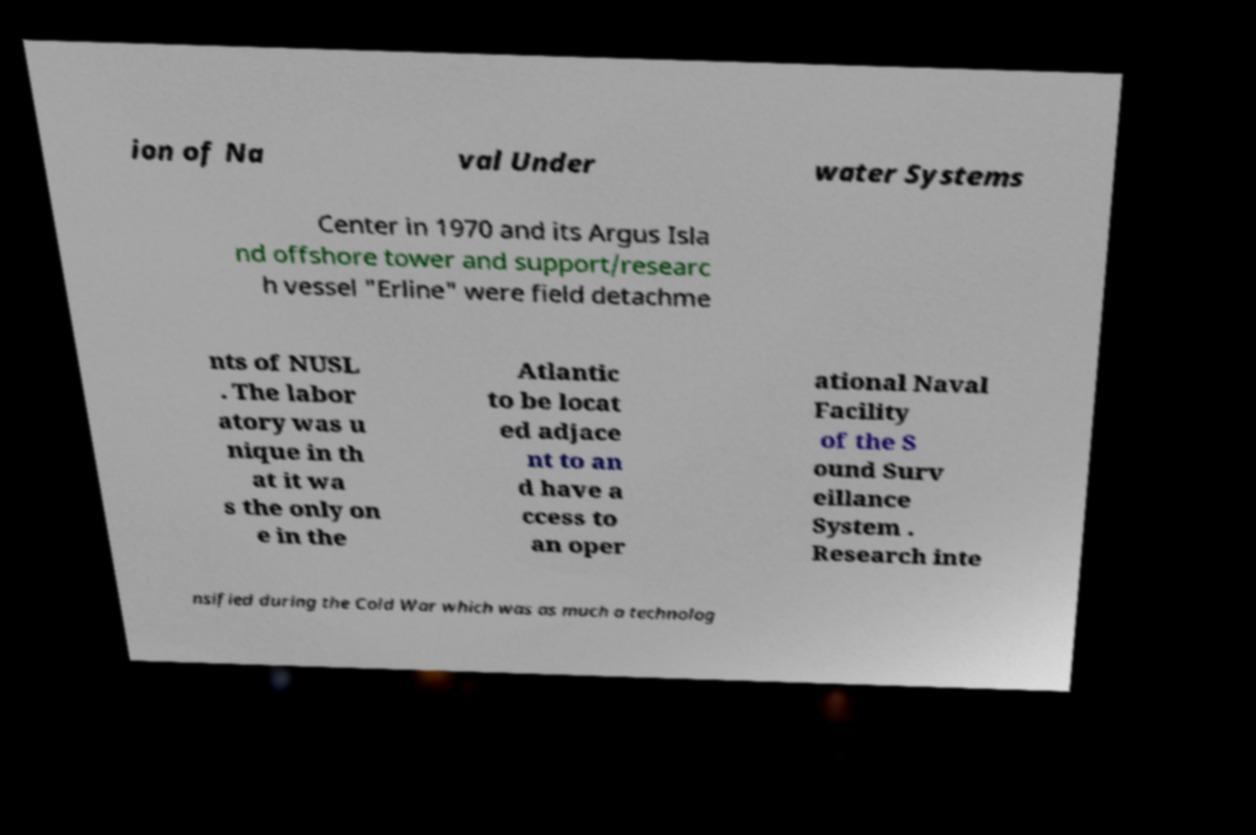I need the written content from this picture converted into text. Can you do that? ion of Na val Under water Systems Center in 1970 and its Argus Isla nd offshore tower and support/researc h vessel "Erline" were field detachme nts of NUSL . The labor atory was u nique in th at it wa s the only on e in the Atlantic to be locat ed adjace nt to an d have a ccess to an oper ational Naval Facility of the S ound Surv eillance System . Research inte nsified during the Cold War which was as much a technolog 